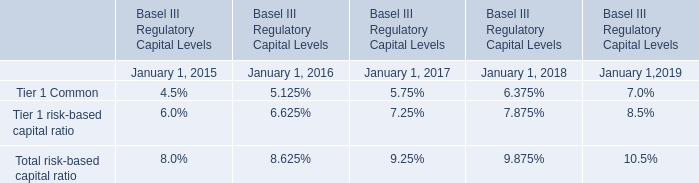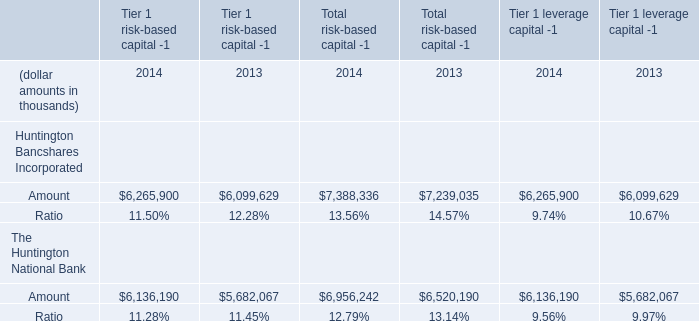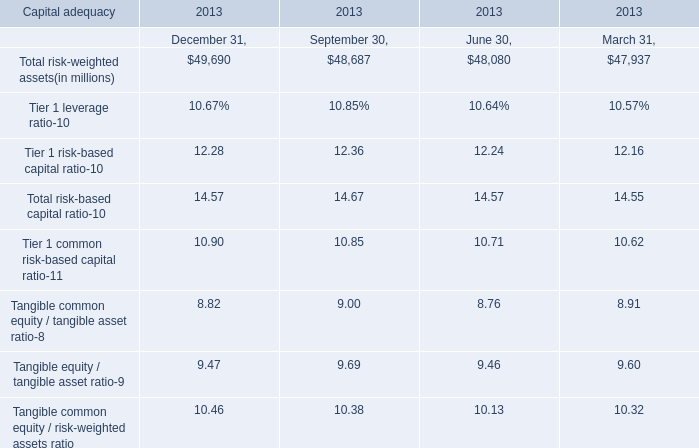In the section with largest value of Total risk-weighted assets, what's the Tier 1 leverage ratio ? 
Answer: 0.1067. 